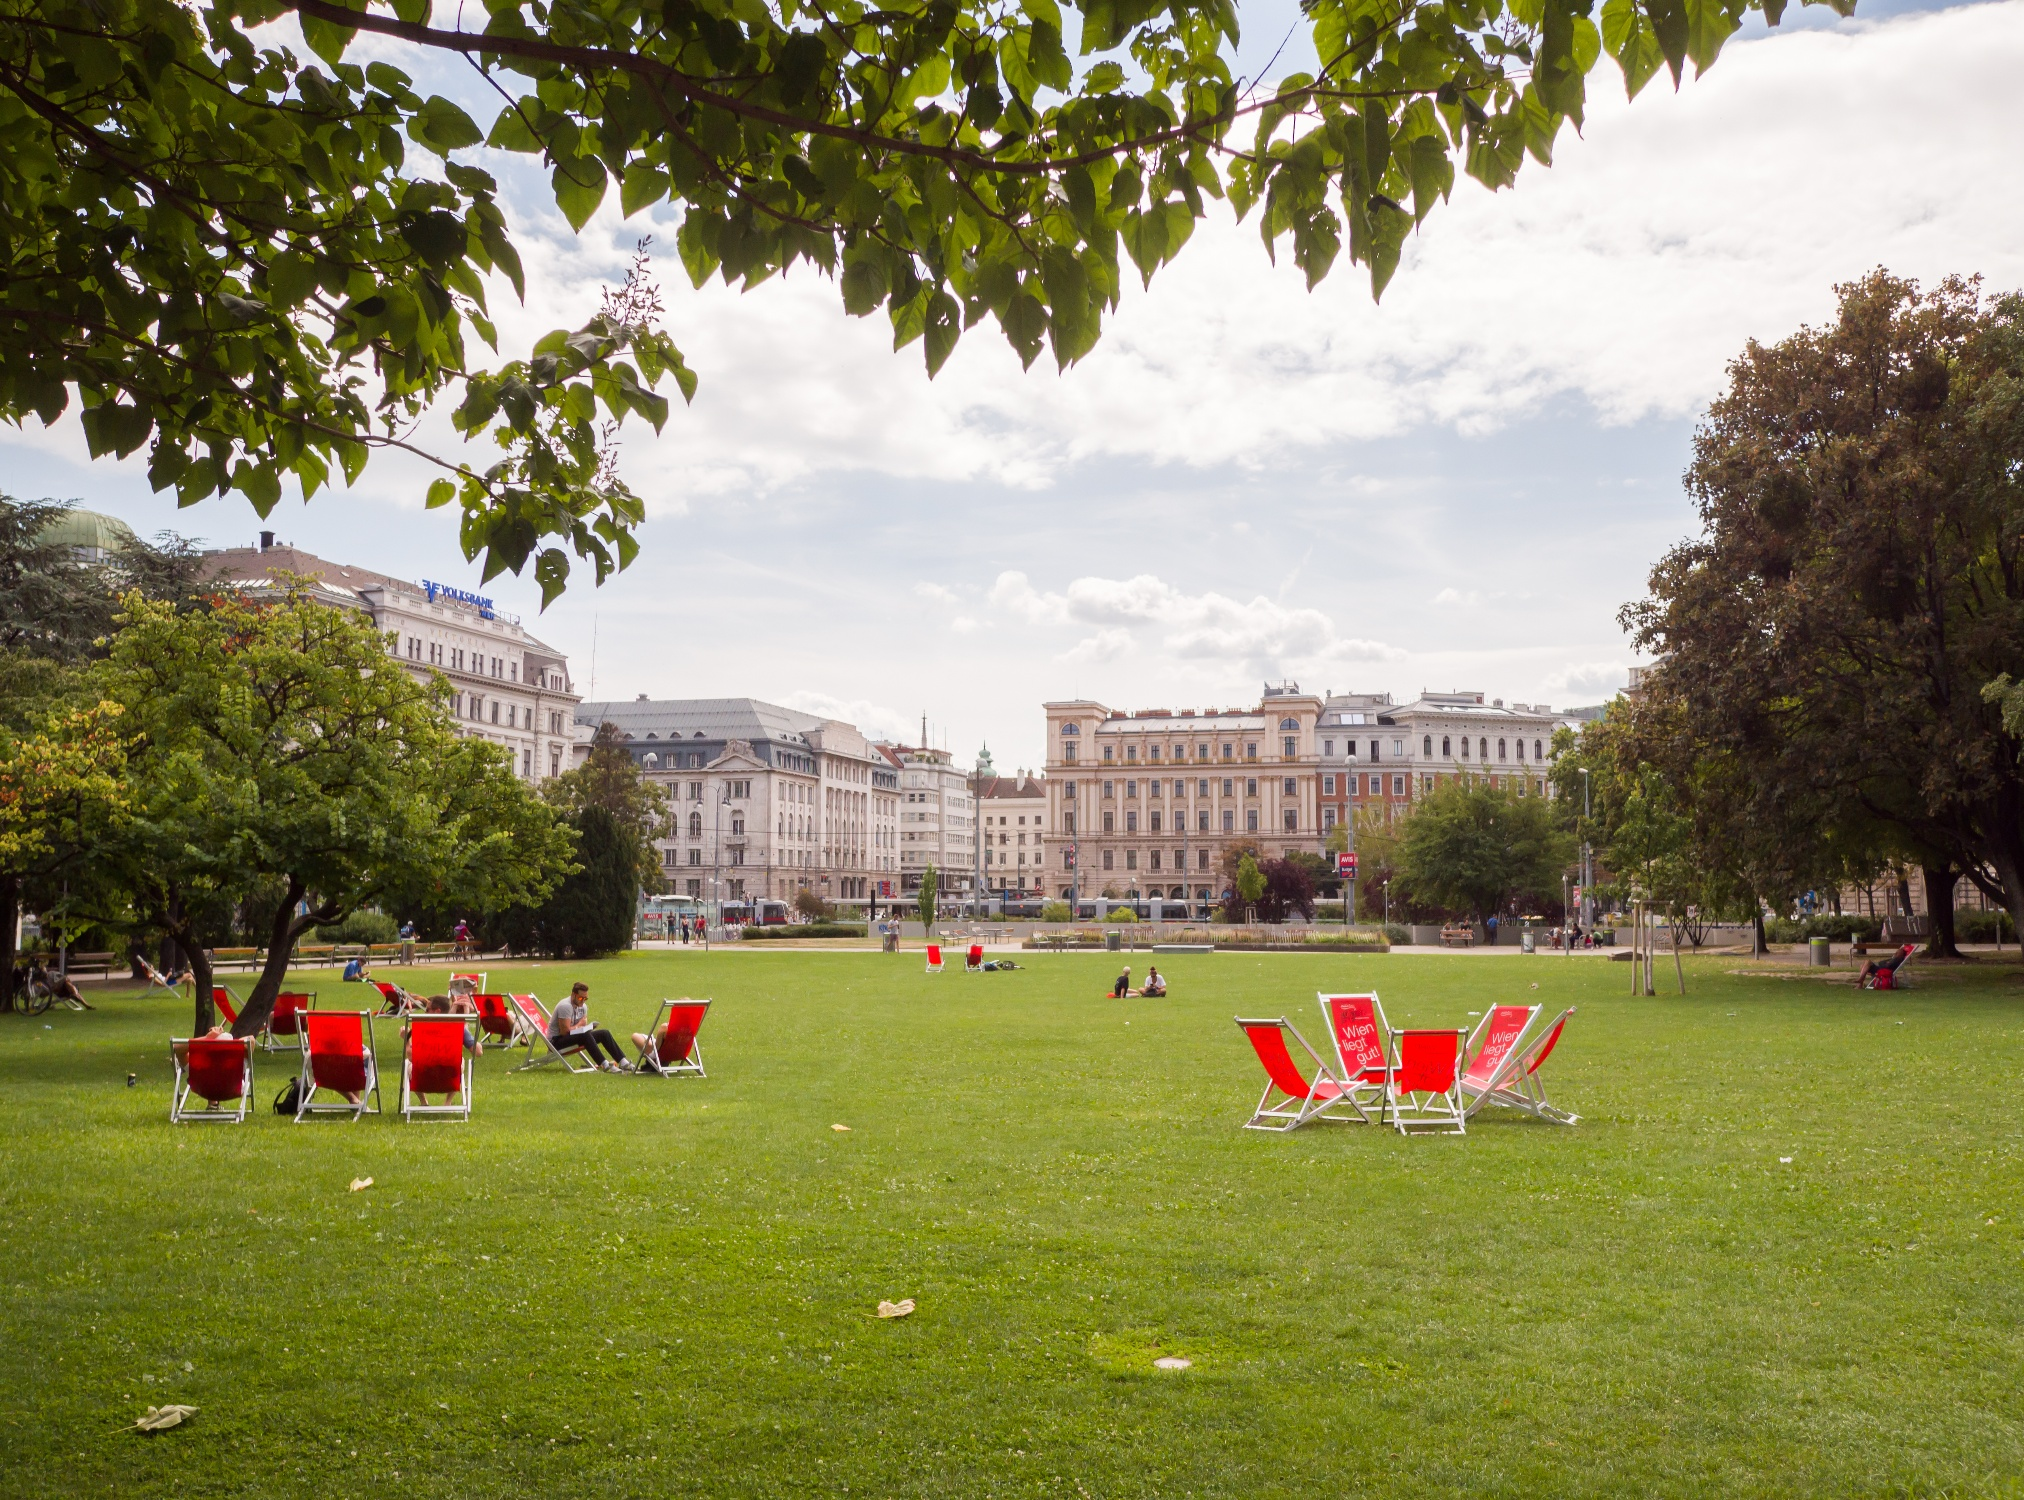What do you think is going on in this snapshot? The image showcases a relaxing afternoon at Jardin Anglais in Geneva. People are enjoying the mild weather by sitting on distinct red chairs spread across the grassy expanse. This setting invites visitors to take a break and soak in the serene environment, surrounded by the impressive architecture of Geneva's cityscape. The clear sky and healthy green trees create a backdrop that contrasts strikingly with the urban buildings, offering a perfect blend of nature and architecture that characterizes the park. 